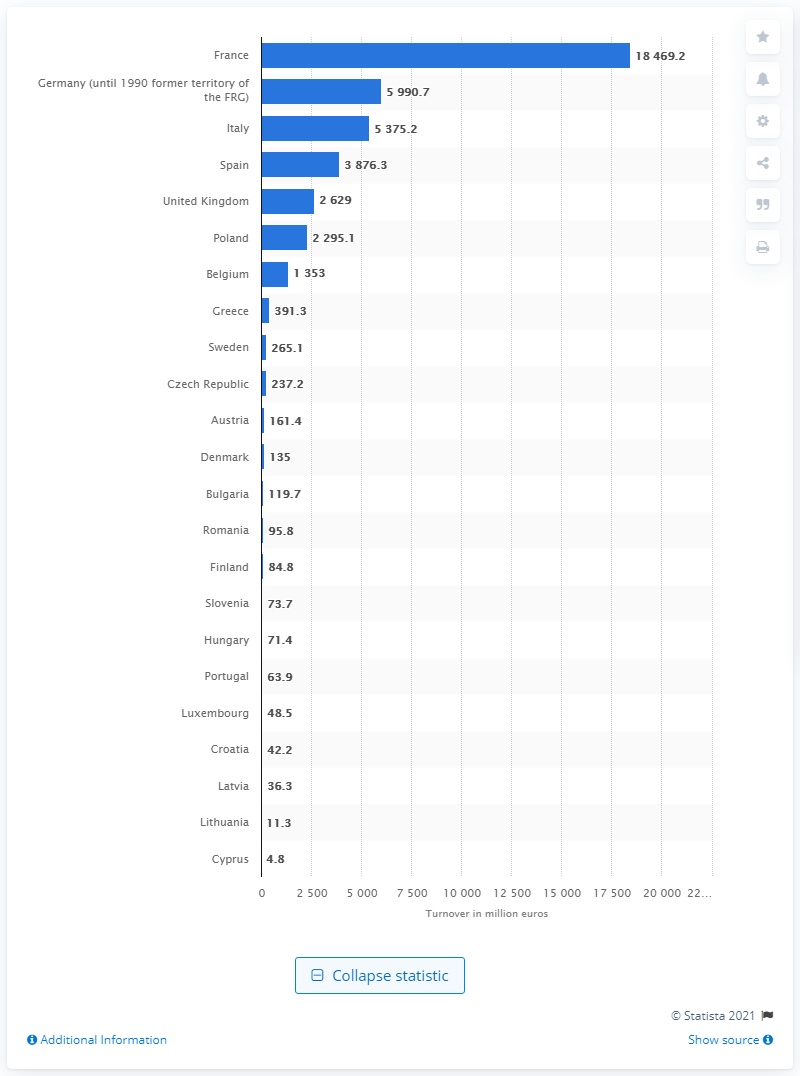Outline some significant characteristics in this image. In 2016, the turnover of manufacturers in France was 18,469.2 million euros. 